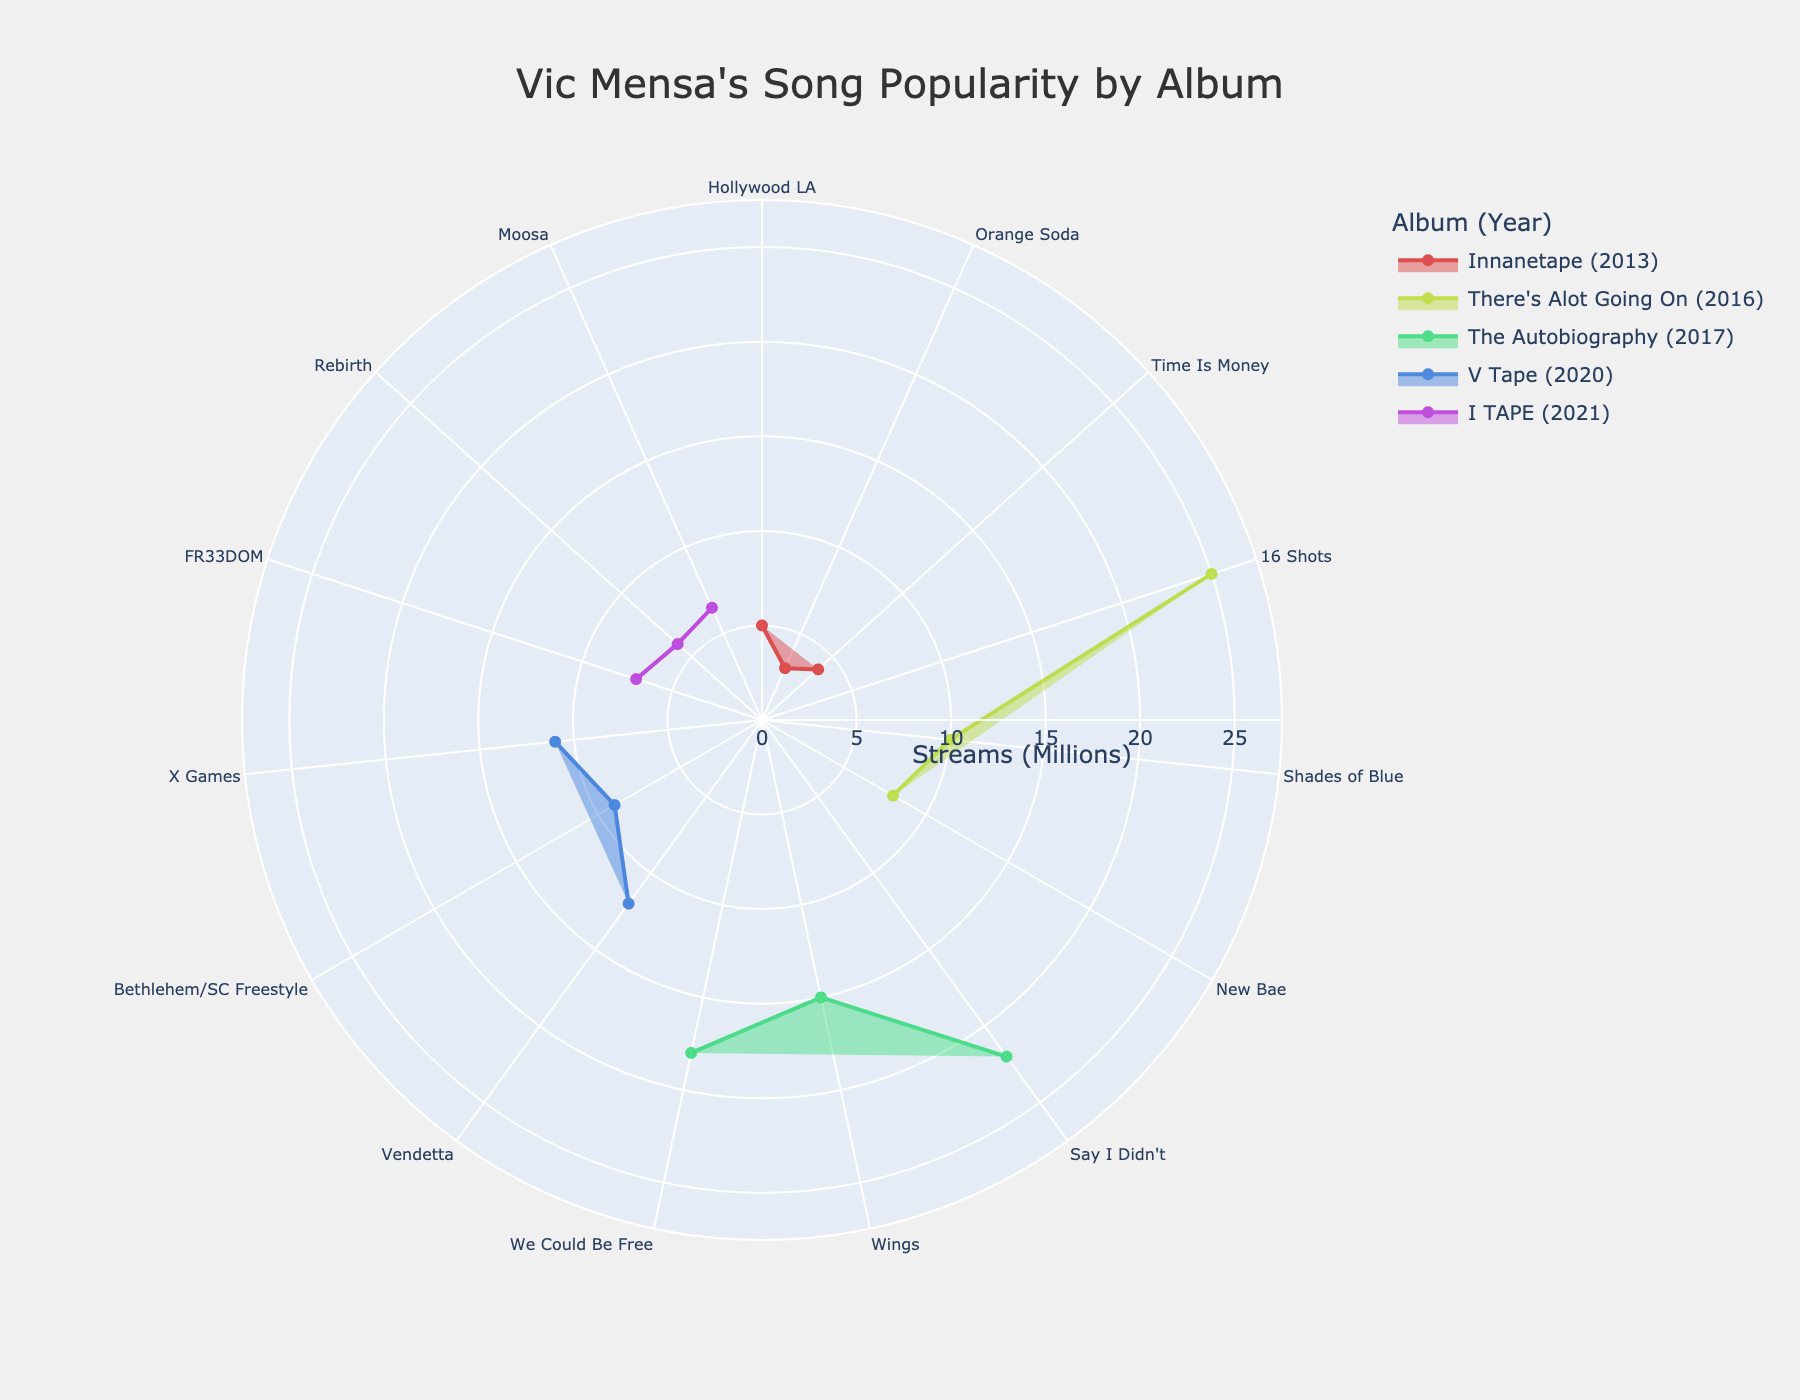what is the title of the figure? The title is always displayed at the top of the figure. In this case, it mentions Vic Mensa and his song popularity.
Answer: Vic Mensa's Song Popularity by Album How many albums are represented in the chart? The figure contains a legend that lists all albums, grouped by year. Counting these unique groups gives us the total number.
Answer: 5 Which album has the highest Spotify streams for a single song, and what is the song title? By looking at the radial lengths, the longest radius corresponds to the highest Spotify streams. In this case, "16 Shots" from the album "There's Alot Going On" is the longest.
Answer: There's Alot Going On, 16 Shots How do the songs from "The Autobiography" compare in popularity? By comparing the radial lengths of the songs within "The Autobiography", we see that "Say I Didn't" has the longest radius, followed by "We Could Be Free" and "Wings".
Answer: Say I Didn't > We Could Be Free > Wings What color represents the album released in 2013? The color scale assigns different hues to different years. Observing the hue for the 2013 album in the legend, we can determine the color.
Answer: A shade of blue Which album has the smallest variation in Spotify streams among its songs? By observing the lengths of radials within each album and identifying the album with the most similar lengths for all songs, we see "I TAPE".
Answer: I TAPE What is the average Spotify streams (in millions) of the songs in "V Tape"? Sum up the radial lengths for "V Tape" songs and divide by the number of songs. (12 + 9 + 11) / 3 = 10.67 million.
Answer: 10.67 million Which year had the highest cumulative Spotify streams based on the chart? Sum the stream values for each year and compare. The year 2016 has "16 Shots" (25) + "Shades of Blue" (10) + "New Bae" (8) = 43 million streams, which is higher than other years.
Answer: 2016 Which song from "Innanetape" has the most Spotify streams, and how many streams does it have? Observing the radials within "Innanetape", "Hollywood LA" has the longest radius. It represents 5 million streams.
Answer: Hollywood LA, 5 million Which album appears to have used the most vibrant colors? Vibrancy is subjective but being asked, we refer to albums with highly saturated colors, indicating recent years. "V Tape" and "I TAPE" use vibrant hues.
Answer: V Tape and I TAPE 